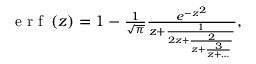<formula> <loc_0><loc_0><loc_500><loc_500>\begin{array} { r } { e r f \left ( z \right ) = 1 - \frac { 1 } { \sqrt { \pi } } \frac { e ^ { - z ^ { 2 } } } { z + \frac { 1 } { 2 z + \frac { 2 } { z + \frac { 3 } { z + \dots } } } } , } \end{array}</formula> 